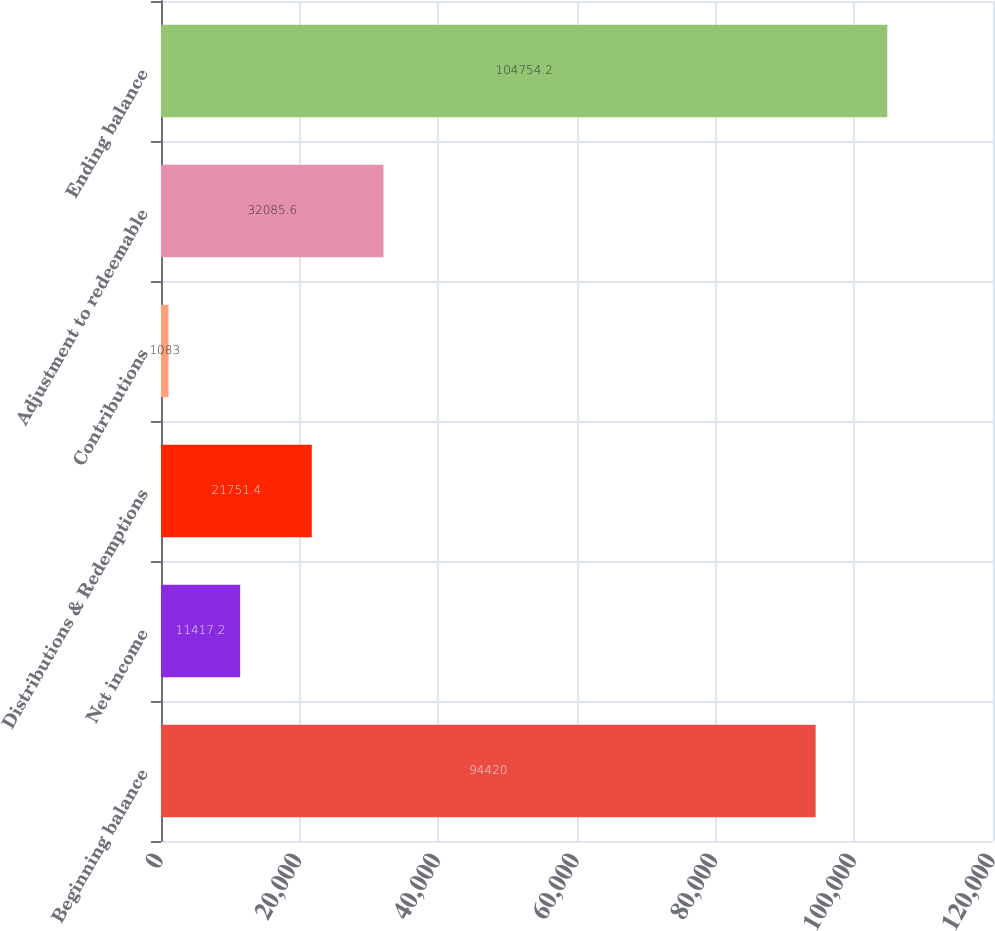Convert chart to OTSL. <chart><loc_0><loc_0><loc_500><loc_500><bar_chart><fcel>Beginning balance<fcel>Net income<fcel>Distributions & Redemptions<fcel>Contributions<fcel>Adjustment to redeemable<fcel>Ending balance<nl><fcel>94420<fcel>11417.2<fcel>21751.4<fcel>1083<fcel>32085.6<fcel>104754<nl></chart> 